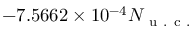Convert formula to latex. <formula><loc_0><loc_0><loc_500><loc_500>- 7 . 5 6 6 2 \times 1 0 ^ { - 4 } N _ { u . c . }</formula> 